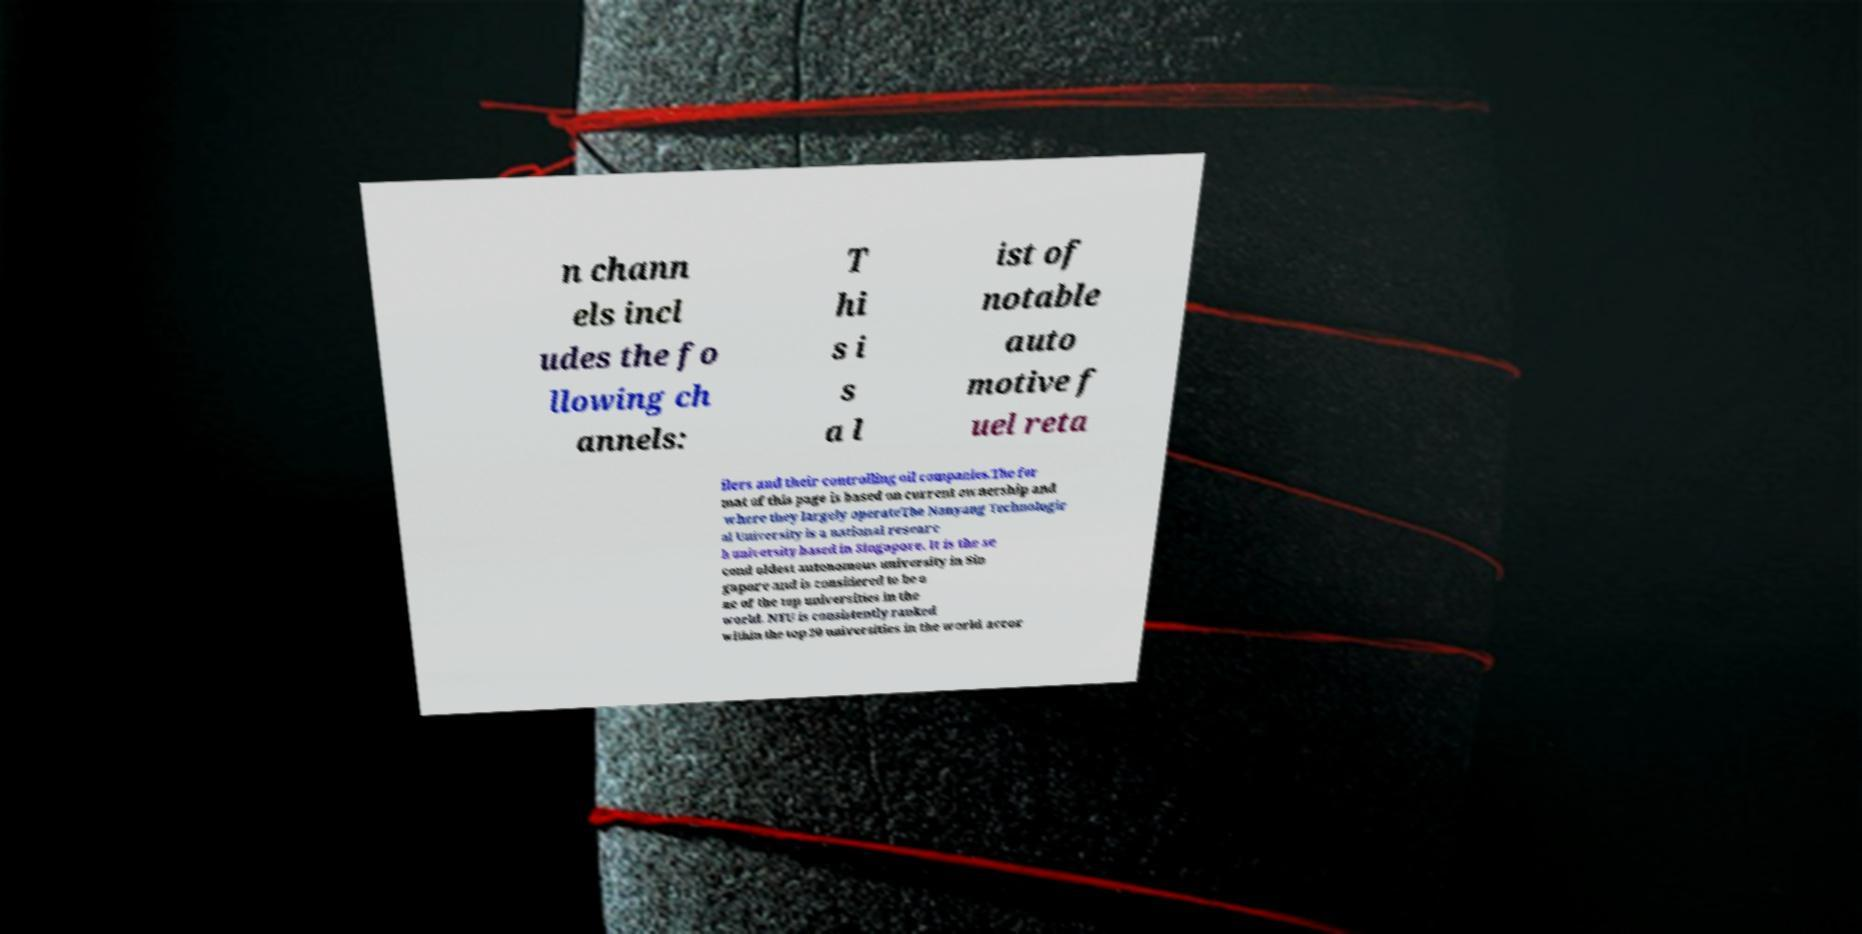Can you read and provide the text displayed in the image?This photo seems to have some interesting text. Can you extract and type it out for me? n chann els incl udes the fo llowing ch annels: T hi s i s a l ist of notable auto motive f uel reta ilers and their controlling oil companies.The for mat of this page is based on current ownership and where they largely operateThe Nanyang Technologic al University is a national researc h university based in Singapore. It is the se cond oldest autonomous university in Sin gapore and is considered to be o ne of the top universities in the world. NTU is consistently ranked within the top 20 universities in the world accor 